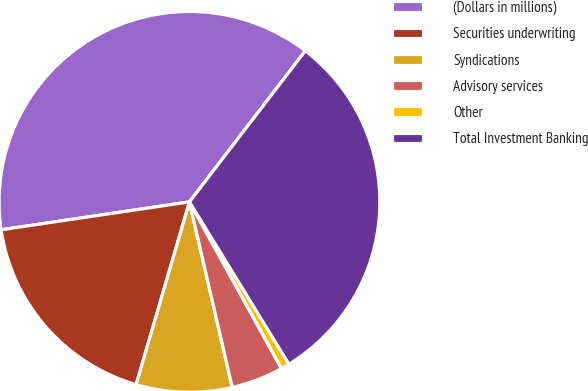<chart> <loc_0><loc_0><loc_500><loc_500><pie_chart><fcel>(Dollars in millions)<fcel>Securities underwriting<fcel>Syndications<fcel>Advisory services<fcel>Other<fcel>Total Investment Banking<nl><fcel>37.76%<fcel>18.14%<fcel>8.13%<fcel>4.42%<fcel>0.72%<fcel>30.84%<nl></chart> 